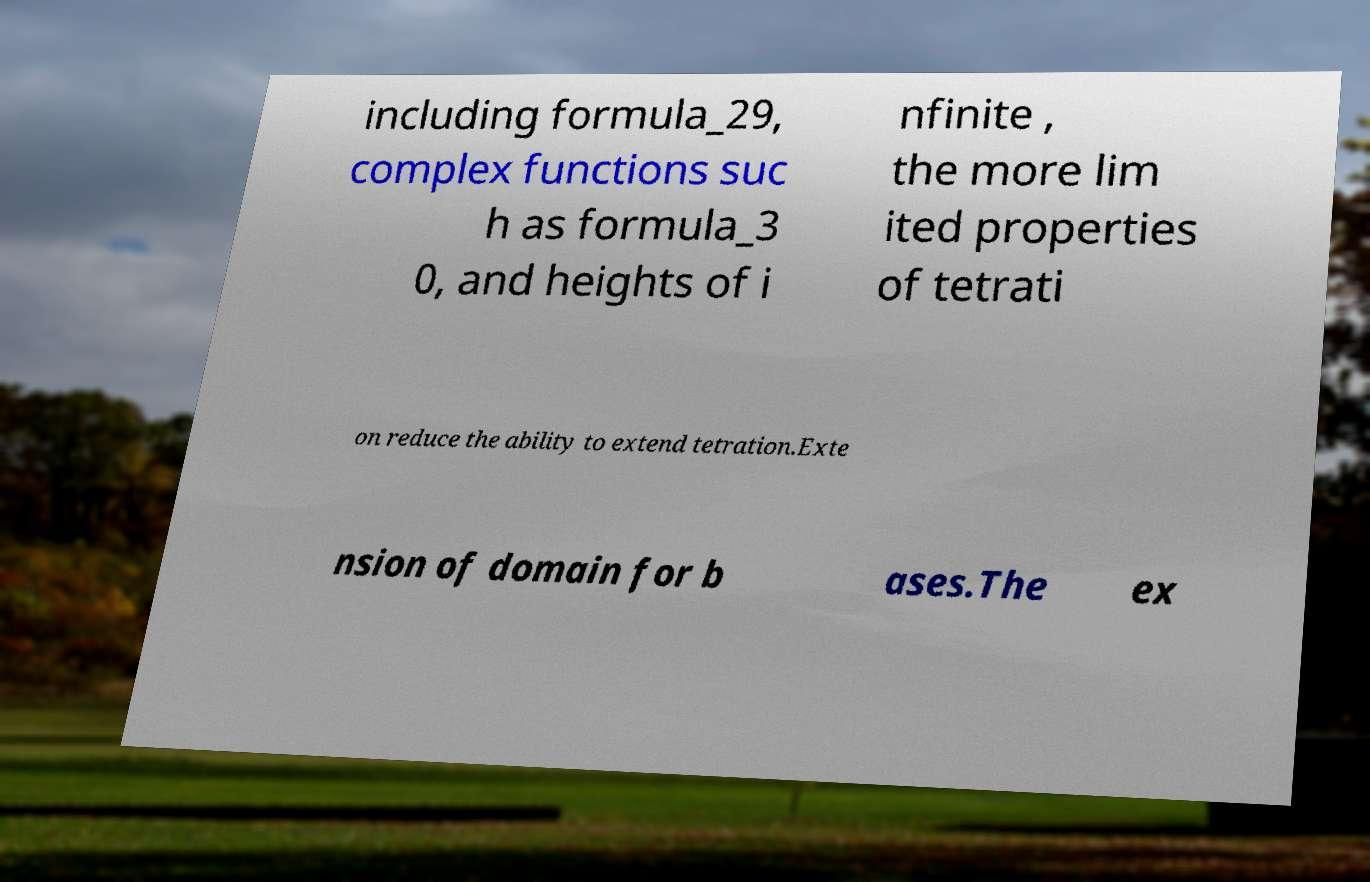Can you read and provide the text displayed in the image?This photo seems to have some interesting text. Can you extract and type it out for me? including formula_29, complex functions suc h as formula_3 0, and heights of i nfinite , the more lim ited properties of tetrati on reduce the ability to extend tetration.Exte nsion of domain for b ases.The ex 